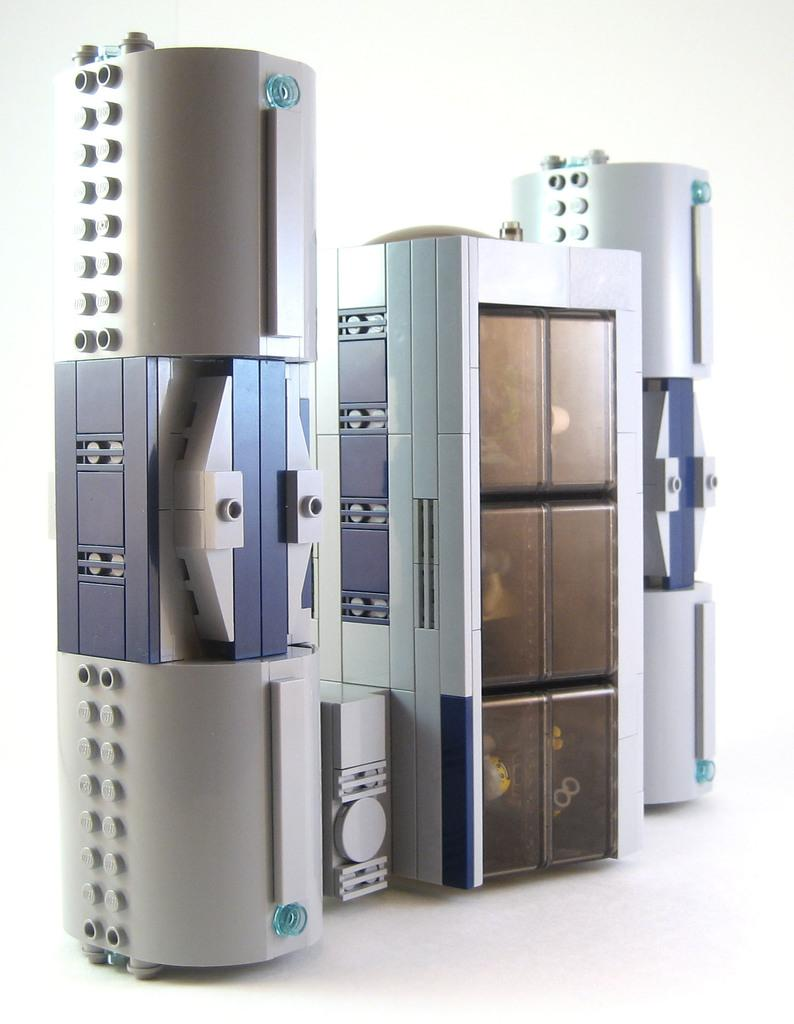What can be seen in the image? There are machines in the image. What is the color of the background in the image? The background of the image is white. What type of discussion is taking place between the machines in the image? There is no discussion taking place between the machines in the image, as they are inanimate objects. What company manufactures the machines in the image? The provided facts do not mention the company that manufactures the machines, so we cannot answer this question. 